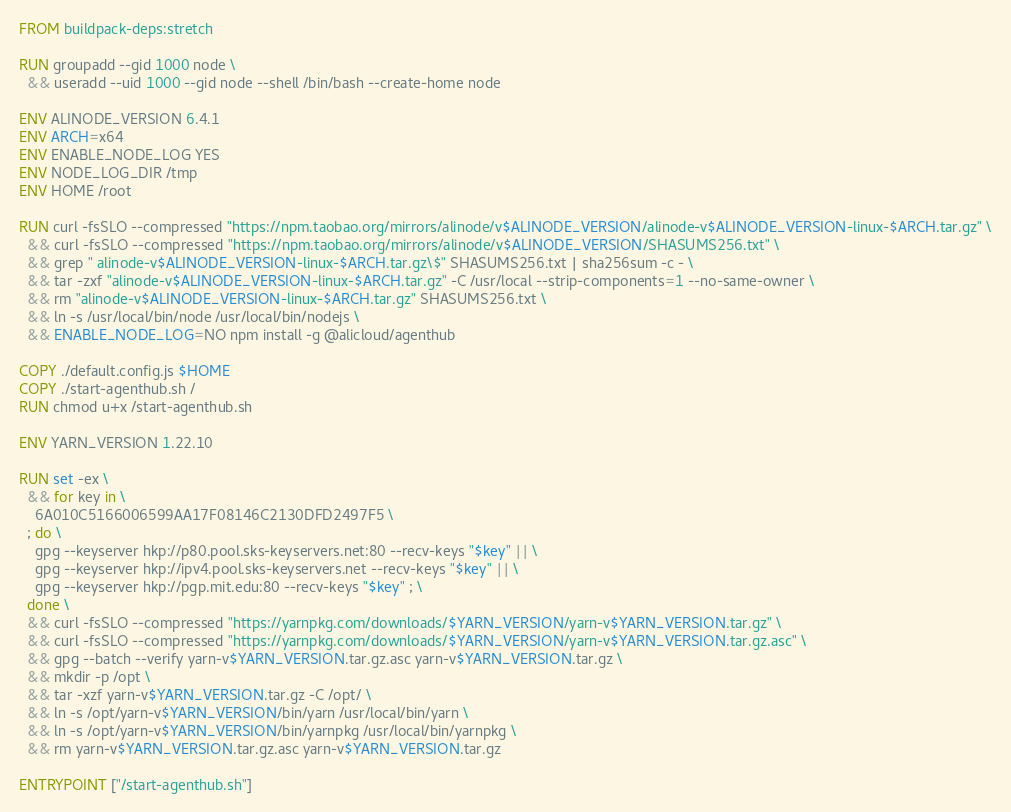<code> <loc_0><loc_0><loc_500><loc_500><_Dockerfile_>FROM buildpack-deps:stretch

RUN groupadd --gid 1000 node \
  && useradd --uid 1000 --gid node --shell /bin/bash --create-home node

ENV ALINODE_VERSION 6.4.1
ENV ARCH=x64
ENV ENABLE_NODE_LOG YES
ENV NODE_LOG_DIR /tmp
ENV HOME /root

RUN curl -fsSLO --compressed "https://npm.taobao.org/mirrors/alinode/v$ALINODE_VERSION/alinode-v$ALINODE_VERSION-linux-$ARCH.tar.gz" \
  && curl -fsSLO --compressed "https://npm.taobao.org/mirrors/alinode/v$ALINODE_VERSION/SHASUMS256.txt" \
  && grep " alinode-v$ALINODE_VERSION-linux-$ARCH.tar.gz\$" SHASUMS256.txt | sha256sum -c - \
  && tar -zxf "alinode-v$ALINODE_VERSION-linux-$ARCH.tar.gz" -C /usr/local --strip-components=1 --no-same-owner \
  && rm "alinode-v$ALINODE_VERSION-linux-$ARCH.tar.gz" SHASUMS256.txt \
  && ln -s /usr/local/bin/node /usr/local/bin/nodejs \
  && ENABLE_NODE_LOG=NO npm install -g @alicloud/agenthub

COPY ./default.config.js $HOME
COPY ./start-agenthub.sh /
RUN chmod u+x /start-agenthub.sh

ENV YARN_VERSION 1.22.10

RUN set -ex \
  && for key in \
    6A010C5166006599AA17F08146C2130DFD2497F5 \
  ; do \
    gpg --keyserver hkp://p80.pool.sks-keyservers.net:80 --recv-keys "$key" || \
    gpg --keyserver hkp://ipv4.pool.sks-keyservers.net --recv-keys "$key" || \
    gpg --keyserver hkp://pgp.mit.edu:80 --recv-keys "$key" ; \
  done \
  && curl -fsSLO --compressed "https://yarnpkg.com/downloads/$YARN_VERSION/yarn-v$YARN_VERSION.tar.gz" \
  && curl -fsSLO --compressed "https://yarnpkg.com/downloads/$YARN_VERSION/yarn-v$YARN_VERSION.tar.gz.asc" \
  && gpg --batch --verify yarn-v$YARN_VERSION.tar.gz.asc yarn-v$YARN_VERSION.tar.gz \
  && mkdir -p /opt \
  && tar -xzf yarn-v$YARN_VERSION.tar.gz -C /opt/ \
  && ln -s /opt/yarn-v$YARN_VERSION/bin/yarn /usr/local/bin/yarn \
  && ln -s /opt/yarn-v$YARN_VERSION/bin/yarnpkg /usr/local/bin/yarnpkg \
  && rm yarn-v$YARN_VERSION.tar.gz.asc yarn-v$YARN_VERSION.tar.gz

ENTRYPOINT ["/start-agenthub.sh"]

</code> 